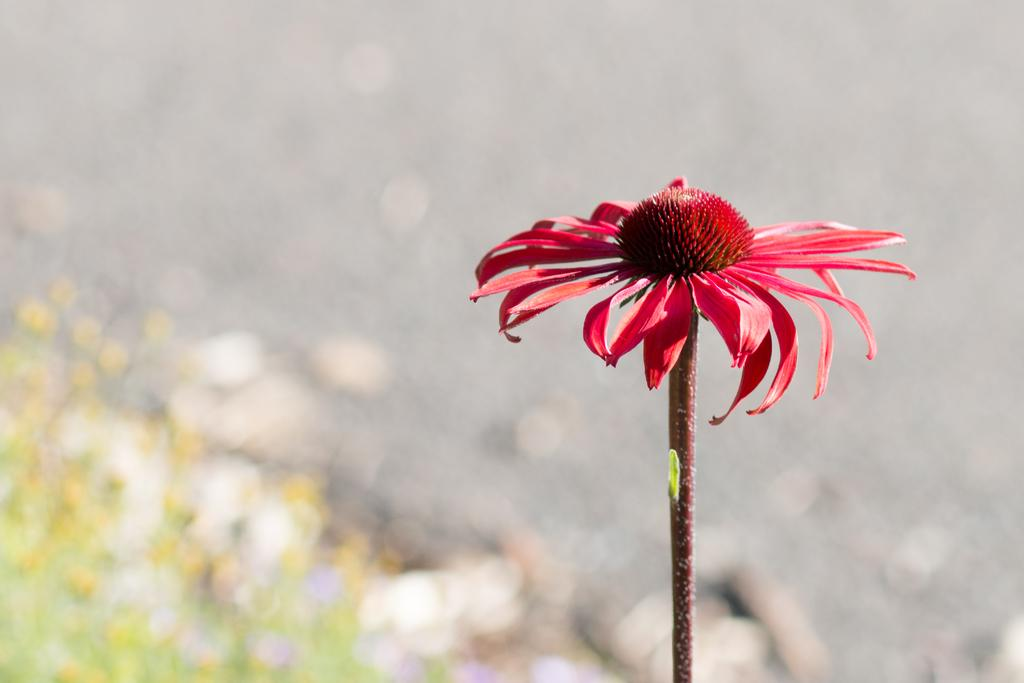What is the main subject of the image? There is a flower in the image. What color is the flower? The flower is red. What type of vegetation is at the bottom of the image? There is grass at the bottom of the image. How would you describe the background of the image? The background of the image is blurred. What type of government is depicted in the image? There is no government depicted in the image; it features a red flower and blurred background. What is the rate of growth for the flower in the image? The image does not provide information about the rate of growth for the flower. 